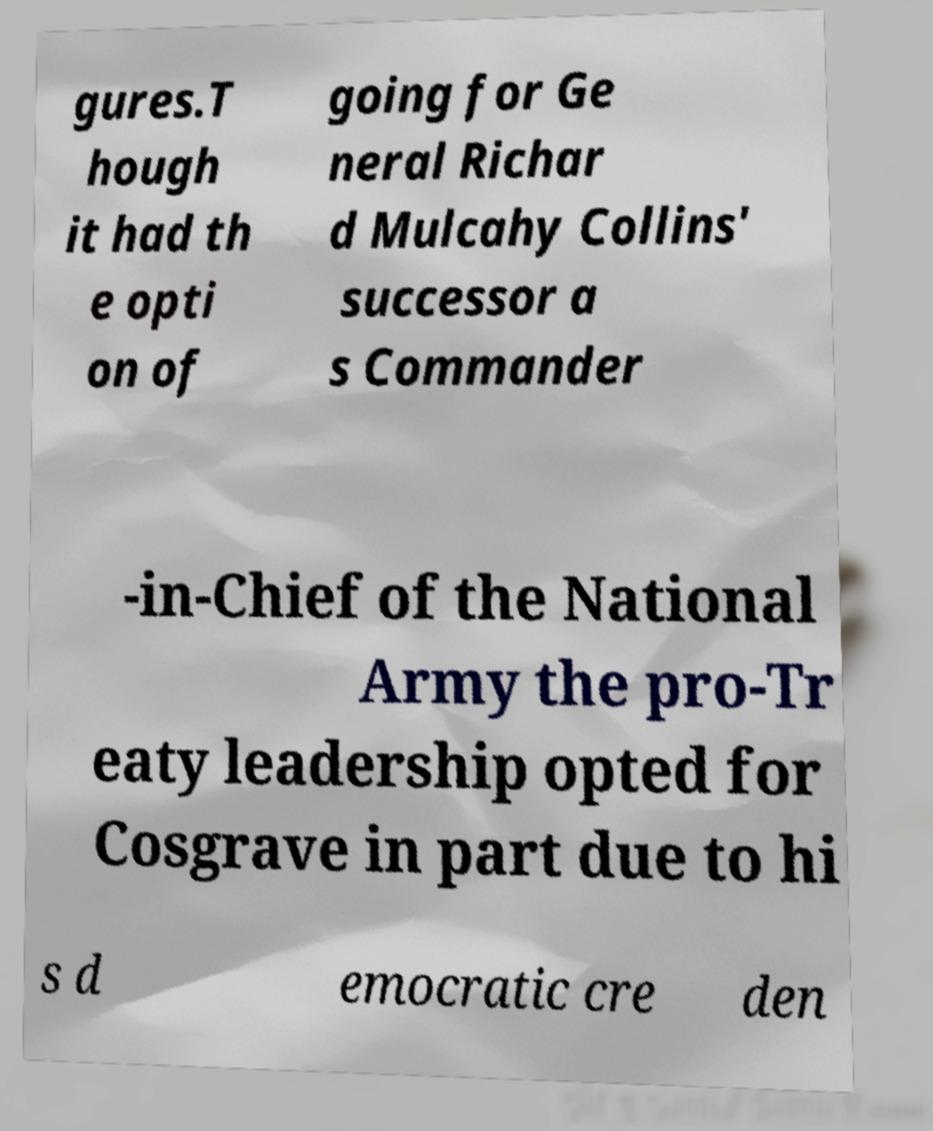There's text embedded in this image that I need extracted. Can you transcribe it verbatim? gures.T hough it had th e opti on of going for Ge neral Richar d Mulcahy Collins' successor a s Commander -in-Chief of the National Army the pro-Tr eaty leadership opted for Cosgrave in part due to hi s d emocratic cre den 